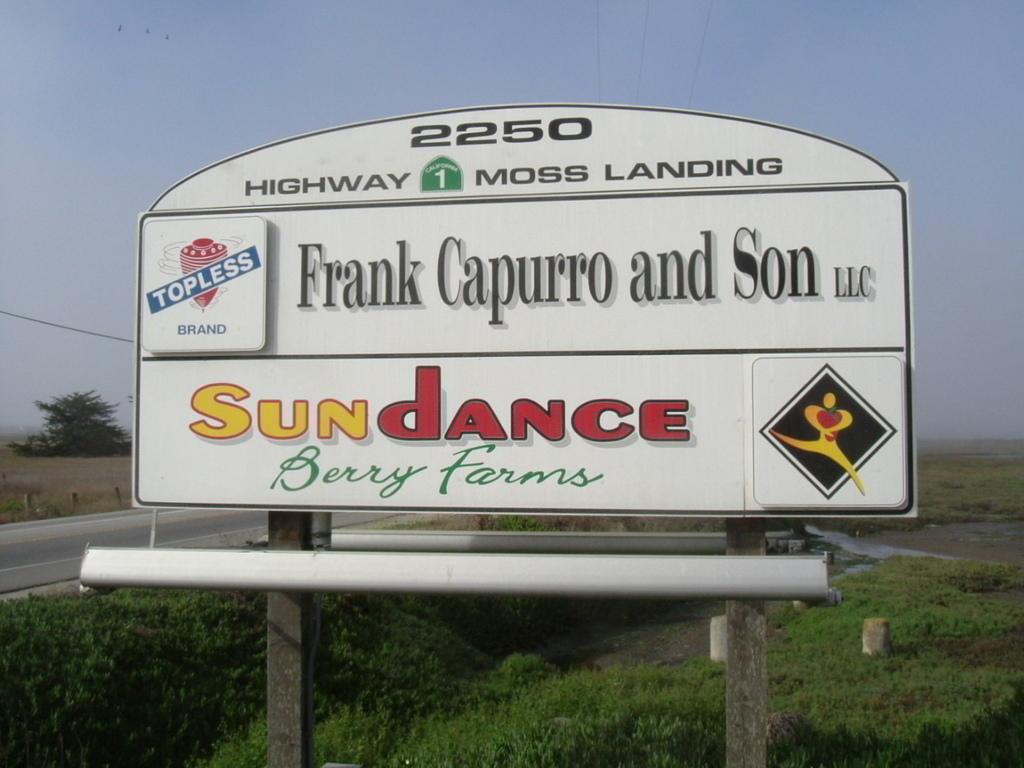What kind of farm is sundance?
Your answer should be compact. Berry farm. What number is at the top of the sign?
Offer a very short reply. 2250. 